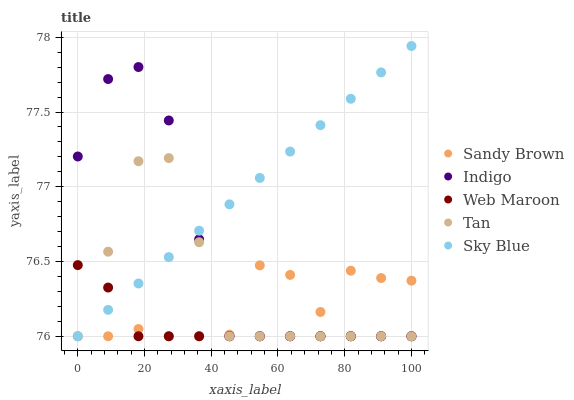Does Web Maroon have the minimum area under the curve?
Answer yes or no. Yes. Does Sky Blue have the maximum area under the curve?
Answer yes or no. Yes. Does Tan have the minimum area under the curve?
Answer yes or no. No. Does Tan have the maximum area under the curve?
Answer yes or no. No. Is Sky Blue the smoothest?
Answer yes or no. Yes. Is Sandy Brown the roughest?
Answer yes or no. Yes. Is Tan the smoothest?
Answer yes or no. No. Is Tan the roughest?
Answer yes or no. No. Does Indigo have the lowest value?
Answer yes or no. Yes. Does Sky Blue have the highest value?
Answer yes or no. Yes. Does Tan have the highest value?
Answer yes or no. No. Does Sky Blue intersect Tan?
Answer yes or no. Yes. Is Sky Blue less than Tan?
Answer yes or no. No. Is Sky Blue greater than Tan?
Answer yes or no. No. 